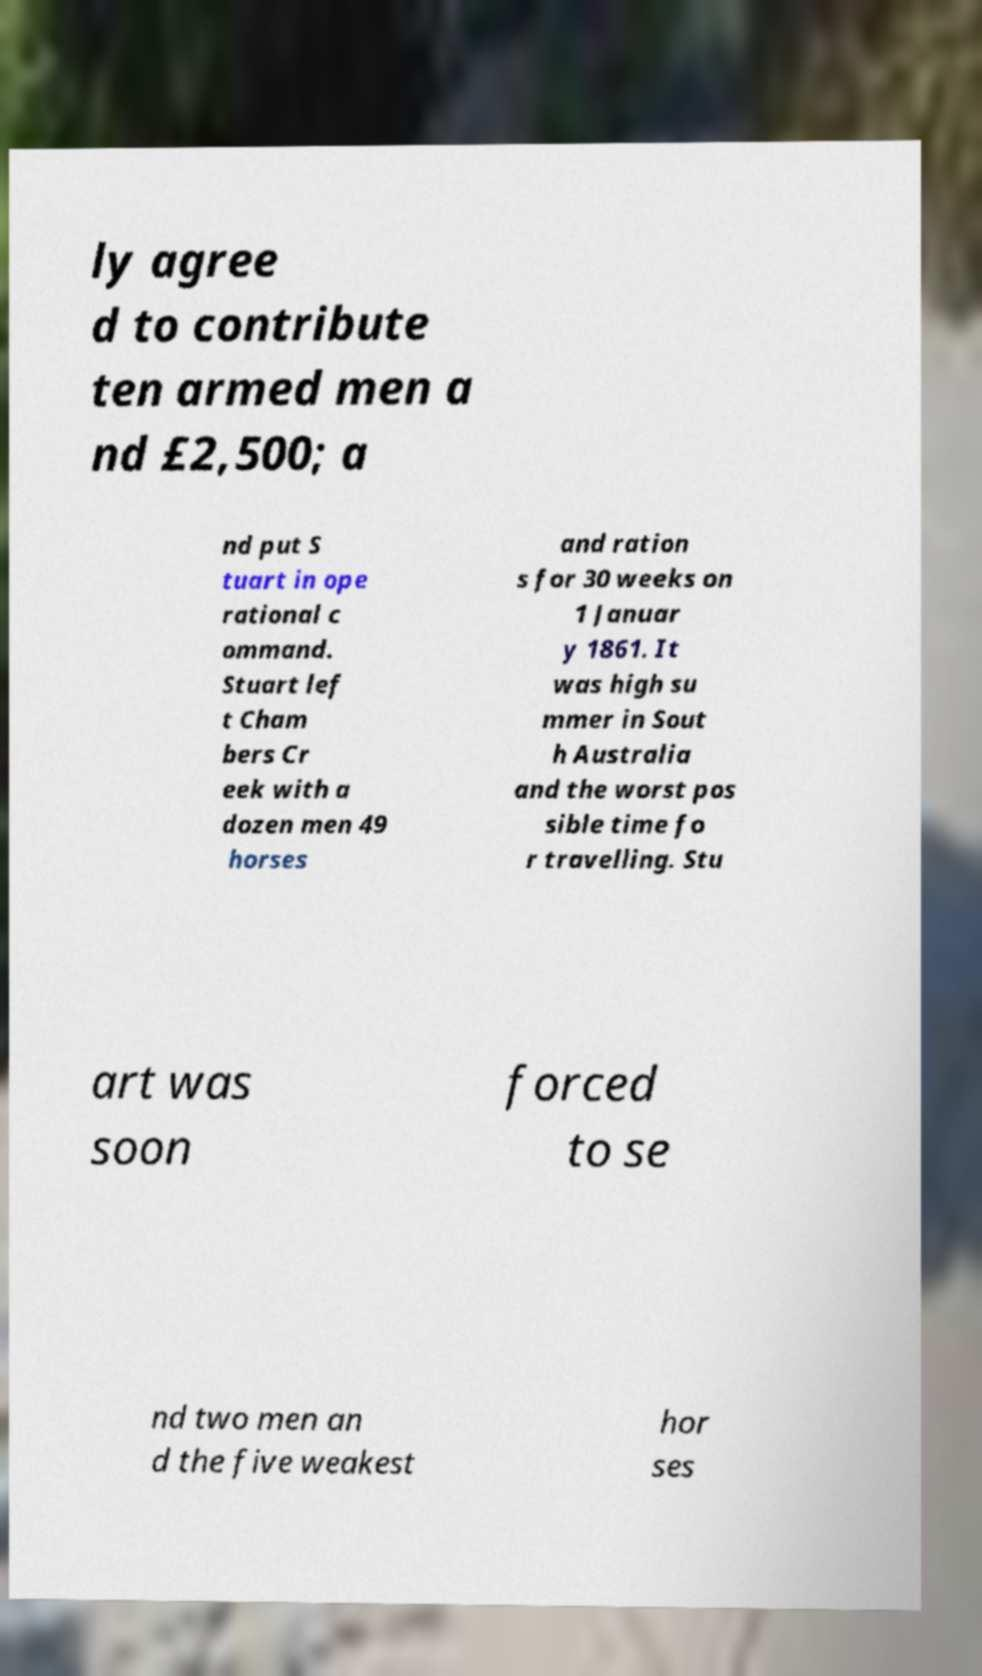Could you assist in decoding the text presented in this image and type it out clearly? ly agree d to contribute ten armed men a nd £2,500; a nd put S tuart in ope rational c ommand. Stuart lef t Cham bers Cr eek with a dozen men 49 horses and ration s for 30 weeks on 1 Januar y 1861. It was high su mmer in Sout h Australia and the worst pos sible time fo r travelling. Stu art was soon forced to se nd two men an d the five weakest hor ses 